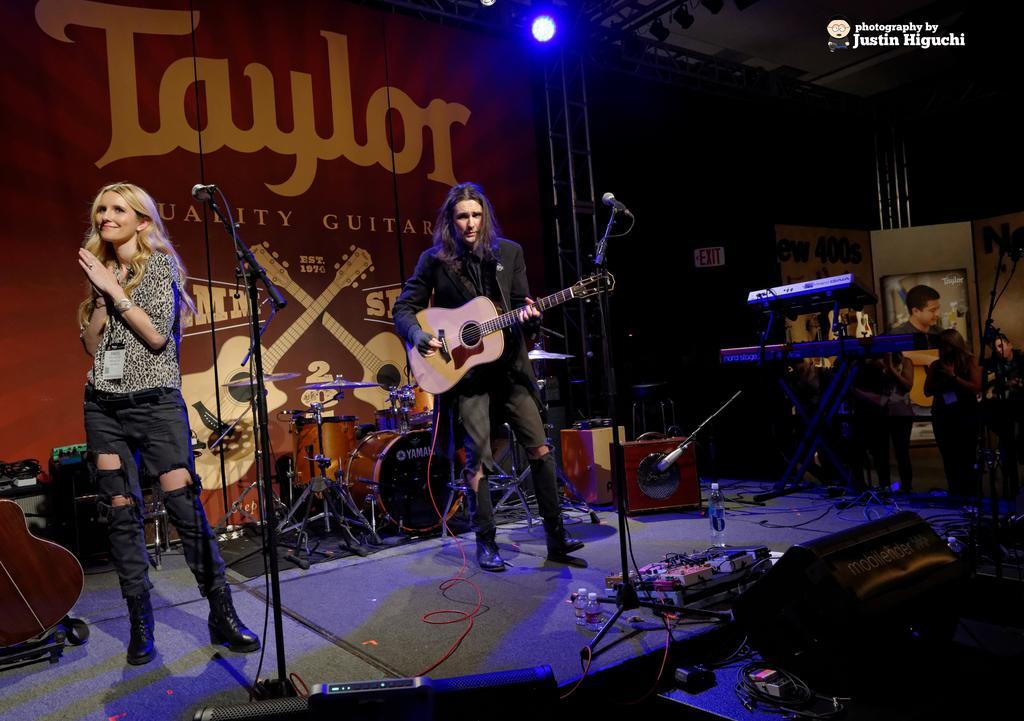Could you give a brief overview of what you see in this image? In the image we can see there is a man who is standing and holding guitar in his hand and beside there is a woman who is standing and in front of her there is a mic with a stand. 